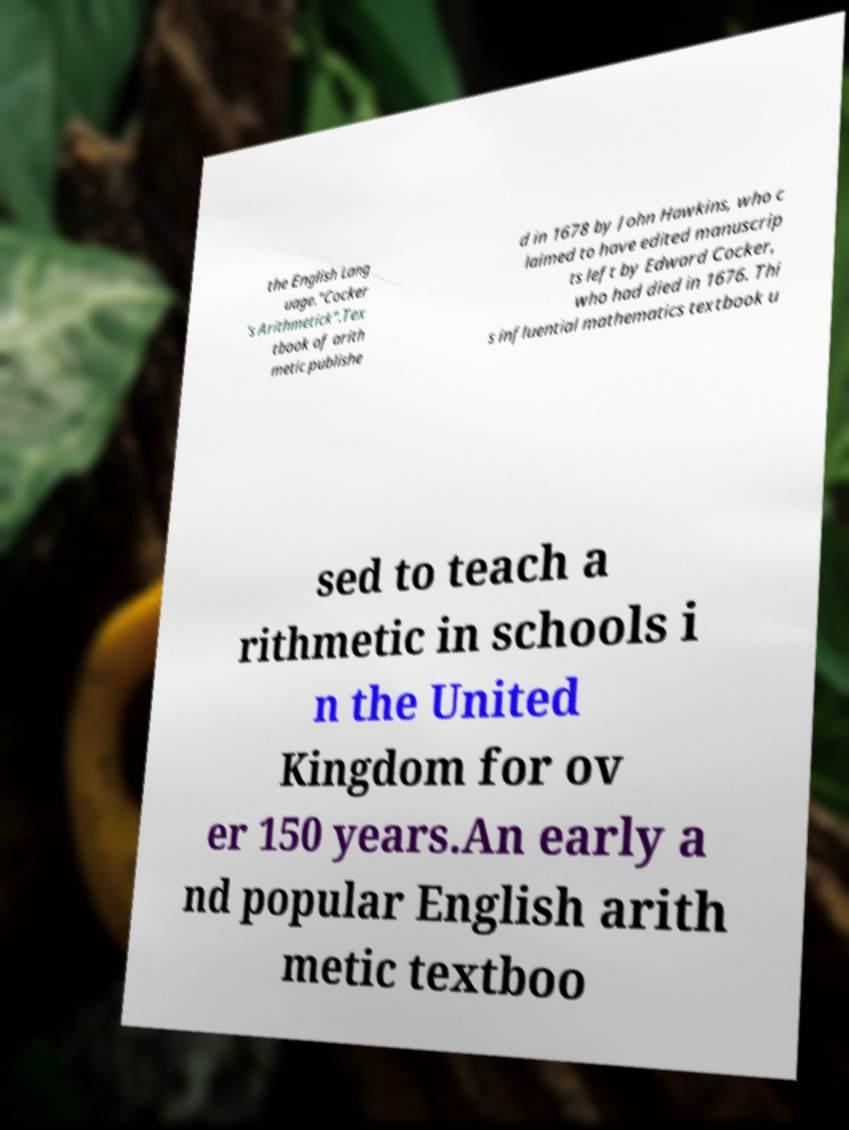Can you accurately transcribe the text from the provided image for me? the English Lang uage."Cocker 's Arithmetick".Tex tbook of arith metic publishe d in 1678 by John Hawkins, who c laimed to have edited manuscrip ts left by Edward Cocker, who had died in 1676. Thi s influential mathematics textbook u sed to teach a rithmetic in schools i n the United Kingdom for ov er 150 years.An early a nd popular English arith metic textboo 